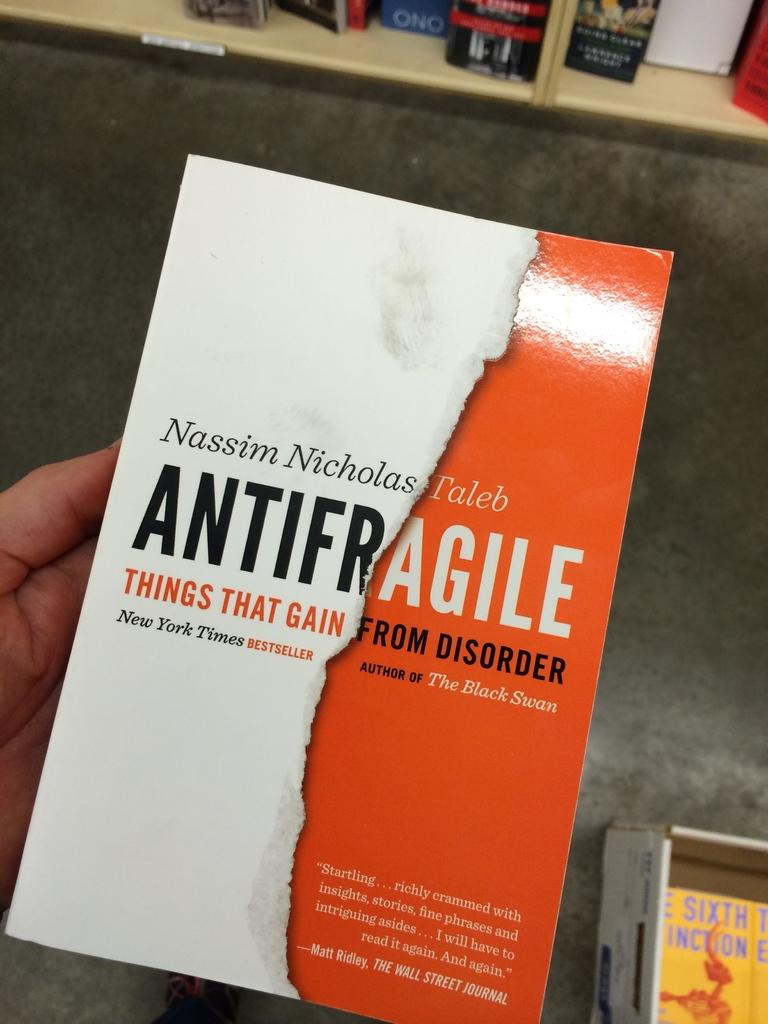What object can be seen in the image that someone might read? There is a book in the image. How is the book being held in the image? The book is being held in someone's hand. What other object can be seen in the bottom right corner of the image? There is a box in the bottom right corner of the image. What type of toothbrush is being used to read the book in the image? There is no toothbrush present in the image, and the book is being held by someone's hand, not being read with a toothbrush. What is the name of the kitten sitting on top of the book in the image? There is no kitten present in the image, so it cannot be sitting on top of the book or have a name. 